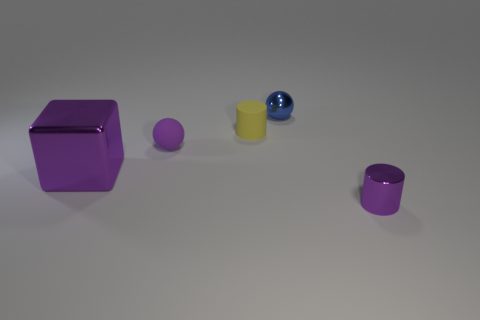Add 5 big shiny objects. How many objects exist? 10 Subtract all balls. How many objects are left? 3 Subtract all rubber things. Subtract all purple metallic cylinders. How many objects are left? 2 Add 2 large metal objects. How many large metal objects are left? 3 Add 2 purple objects. How many purple objects exist? 5 Subtract 1 purple cubes. How many objects are left? 4 